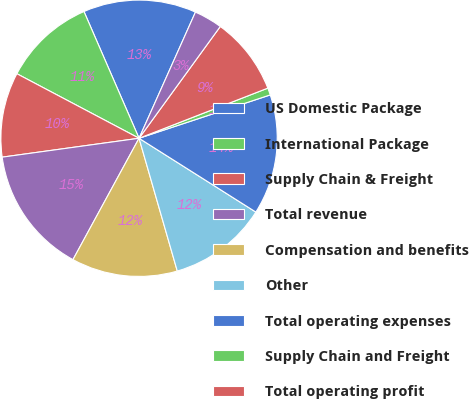Convert chart to OTSL. <chart><loc_0><loc_0><loc_500><loc_500><pie_chart><fcel>US Domestic Package<fcel>International Package<fcel>Supply Chain & Freight<fcel>Total revenue<fcel>Compensation and benefits<fcel>Other<fcel>Total operating expenses<fcel>Supply Chain and Freight<fcel>Total operating profit<fcel>Investment income<nl><fcel>13.22%<fcel>10.74%<fcel>9.92%<fcel>14.88%<fcel>12.4%<fcel>11.57%<fcel>14.05%<fcel>0.83%<fcel>9.09%<fcel>3.31%<nl></chart> 